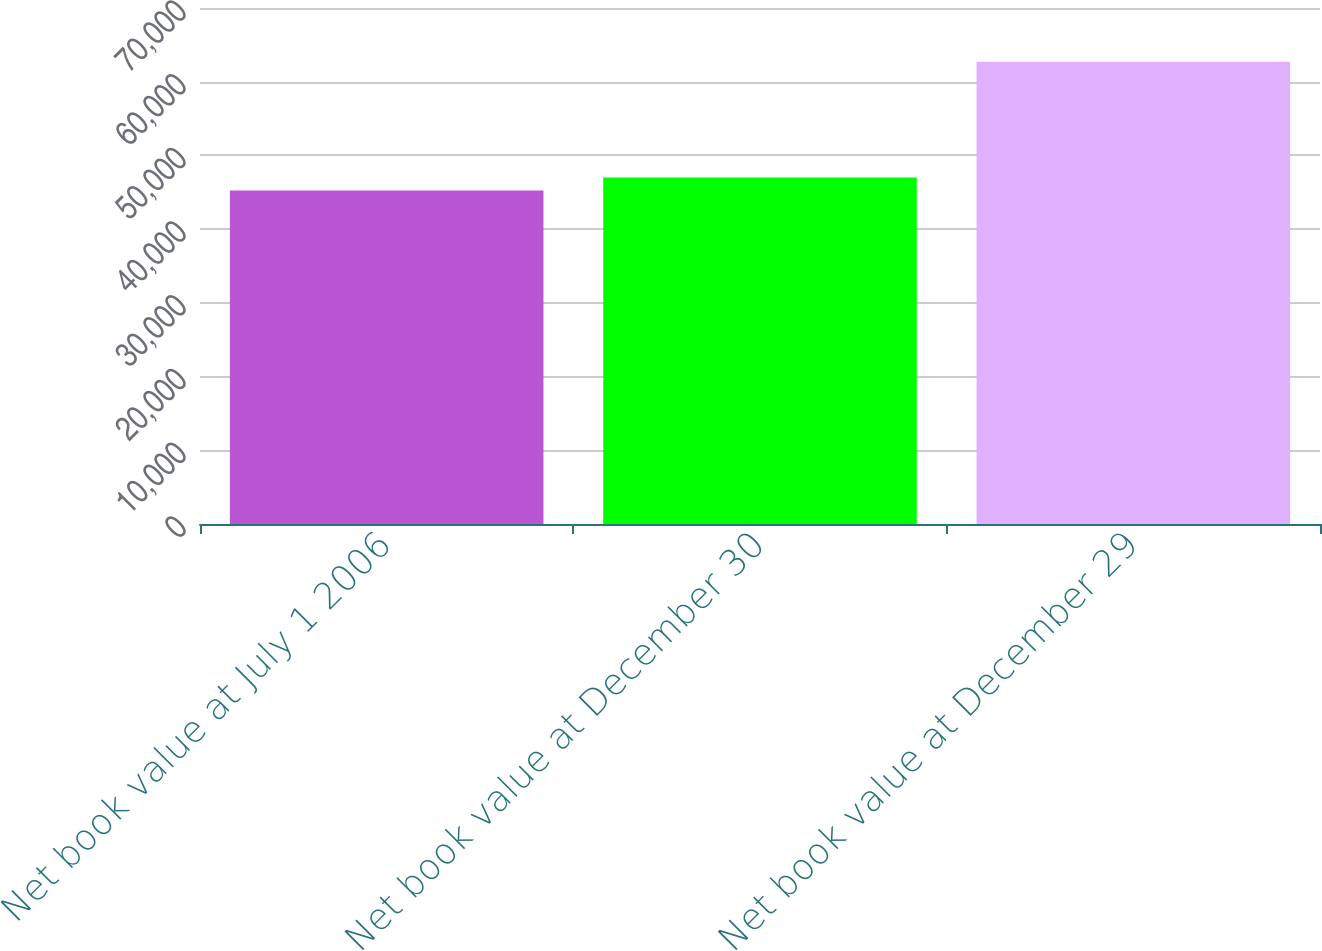Convert chart to OTSL. <chart><loc_0><loc_0><loc_500><loc_500><bar_chart><fcel>Net book value at July 1 2006<fcel>Net book value at December 30<fcel>Net book value at December 29<nl><fcel>45243<fcel>46989.8<fcel>62711<nl></chart> 